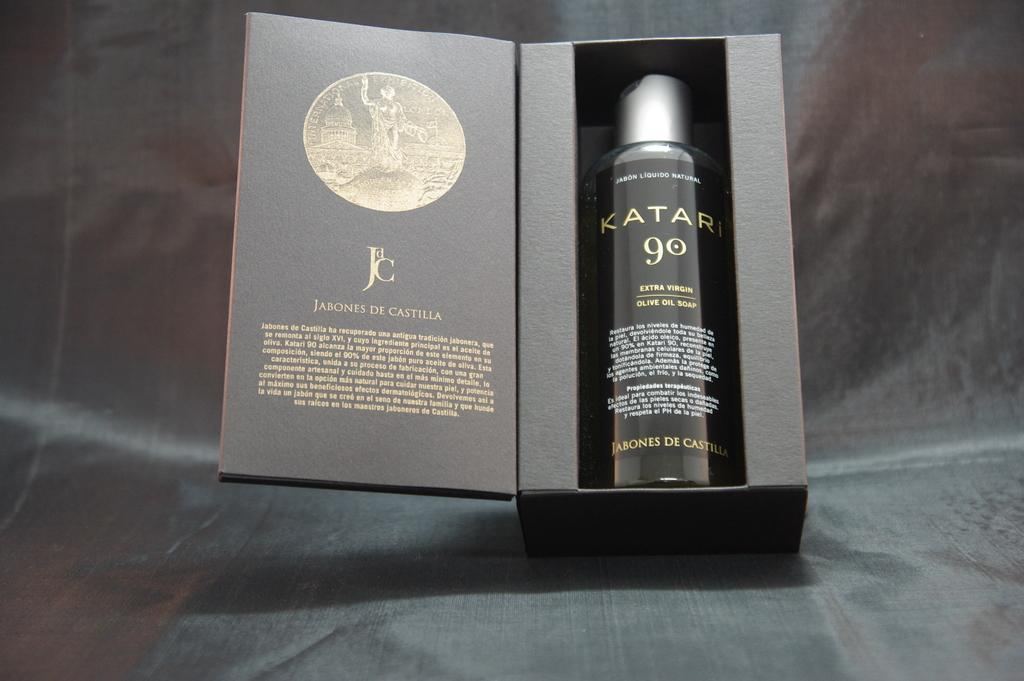<image>
Describe the image concisely. A bottle of some shampoo or spray that says Katari 90. 